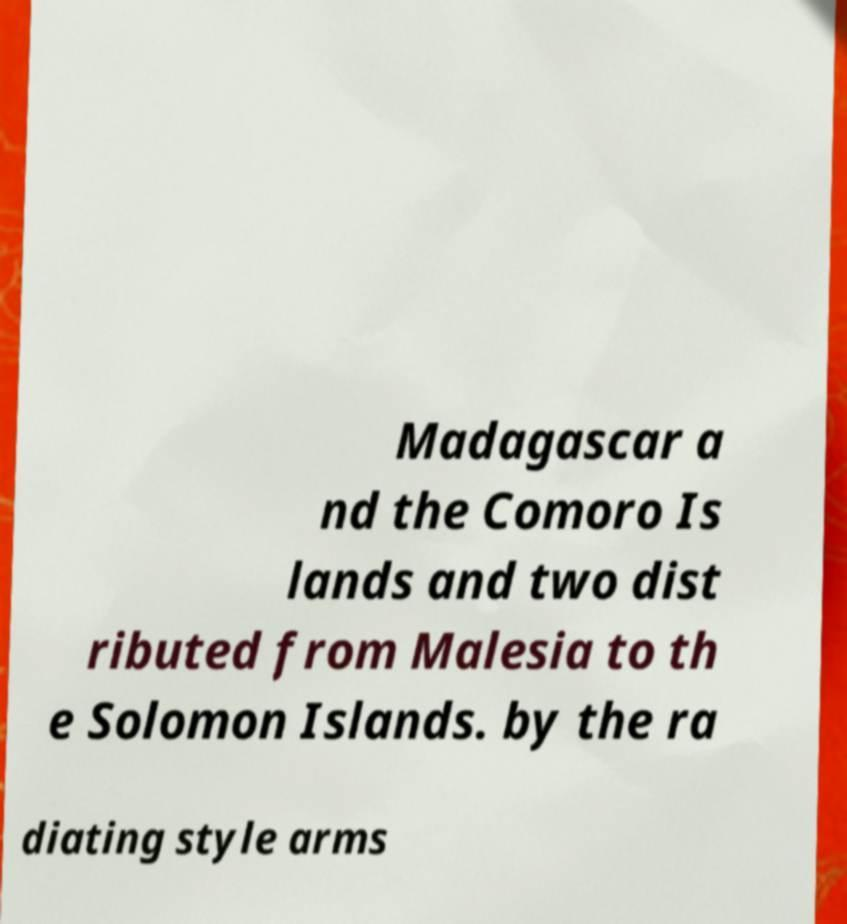What messages or text are displayed in this image? I need them in a readable, typed format. Madagascar a nd the Comoro Is lands and two dist ributed from Malesia to th e Solomon Islands. by the ra diating style arms 